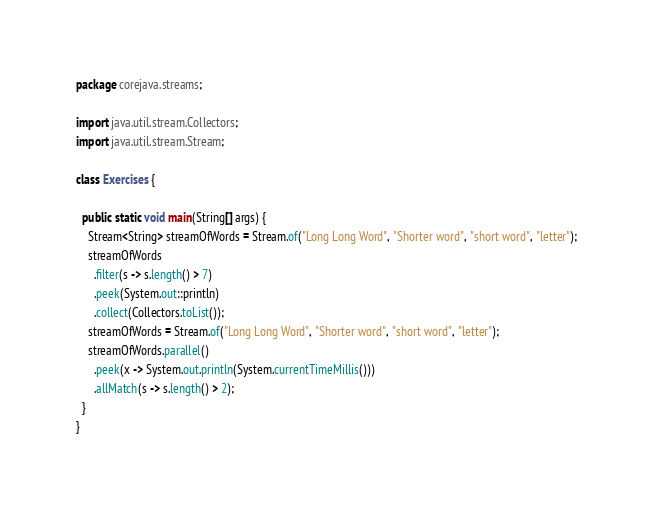Convert code to text. <code><loc_0><loc_0><loc_500><loc_500><_Java_>package corejava.streams;

import java.util.stream.Collectors;
import java.util.stream.Stream;

class Exercises {

  public static void main(String[] args) {
    Stream<String> streamOfWords = Stream.of("Long Long Word", "Shorter word", "short word", "letter");
    streamOfWords
      .filter(s -> s.length() > 7)
      .peek(System.out::println)
      .collect(Collectors.toList());
    streamOfWords = Stream.of("Long Long Word", "Shorter word", "short word", "letter");
    streamOfWords.parallel()
      .peek(x -> System.out.println(System.currentTimeMillis()))
      .allMatch(s -> s.length() > 2);
  }
}
</code> 